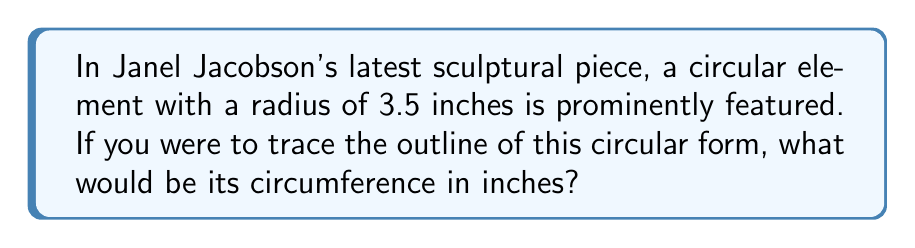Could you help me with this problem? To find the circumference of a circular element, we use the formula:

$$C = 2\pi r$$

Where:
$C$ = circumference
$\pi$ = pi (approximately 3.14159)
$r$ = radius

Given:
$r = 3.5$ inches

Step 1: Substitute the known values into the formula
$$C = 2\pi(3.5)$$

Step 2: Multiply
$$C = 7\pi$$

Step 3: Calculate the final value (using $\pi \approx 3.14159$)
$$C \approx 7 \times 3.14159 = 21.99113$$

Step 4: Round to two decimal places for a practical measurement
$$C \approx 21.99\text{ inches}$$
Answer: $21.99\text{ inches}$ 